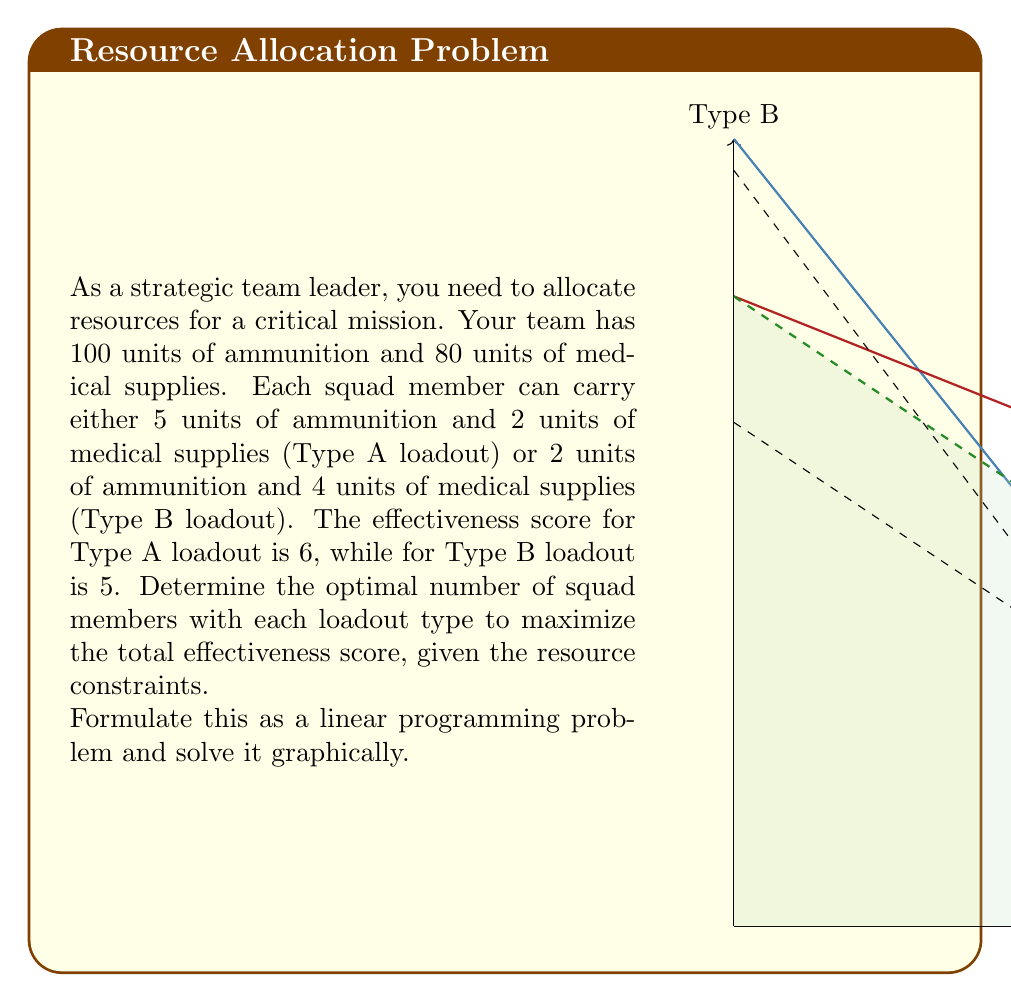Could you help me with this problem? Let's solve this problem step by step:

1) Define variables:
   Let $x$ = number of squad members with Type A loadout
   Let $y$ = number of squad members with Type B loadout

2) Formulate the objective function:
   Maximize $Z = 6x + 5y$ (total effectiveness score)

3) Identify constraints:
   Ammunition constraint: $5x + 2y \leq 100$
   Medical supplies constraint: $2x + 4y \leq 80$
   Non-negativity: $x \geq 0$, $y \geq 0$

4) Simplify constraints:
   $5x + 2y = 100$ simplifies to $y = 50 - 2.5x$
   $2x + 4y = 80$ simplifies to $y = 20 - 0.5x$

5) Plot constraints:
   The blue line represents the ammunition constraint.
   The red line represents the medical supplies constraint.
   The green shaded area is the feasible region.

6) Identify corner points of the feasible region:
   (0,0), (20,0), (15,10), (0,20)

7) Evaluate the objective function at each corner point:
   At (0,0): $Z = 0$
   At (20,0): $Z = 120$
   At (15,10): $Z = 140$
   At (0,20): $Z = 100$

8) The maximum value occurs at (15,10), which is the optimal solution.

Therefore, the optimal allocation is 15 squad members with Type A loadout and 10 squad members with Type B loadout, resulting in a maximum effectiveness score of 140.
Answer: 15 Type A, 10 Type B 